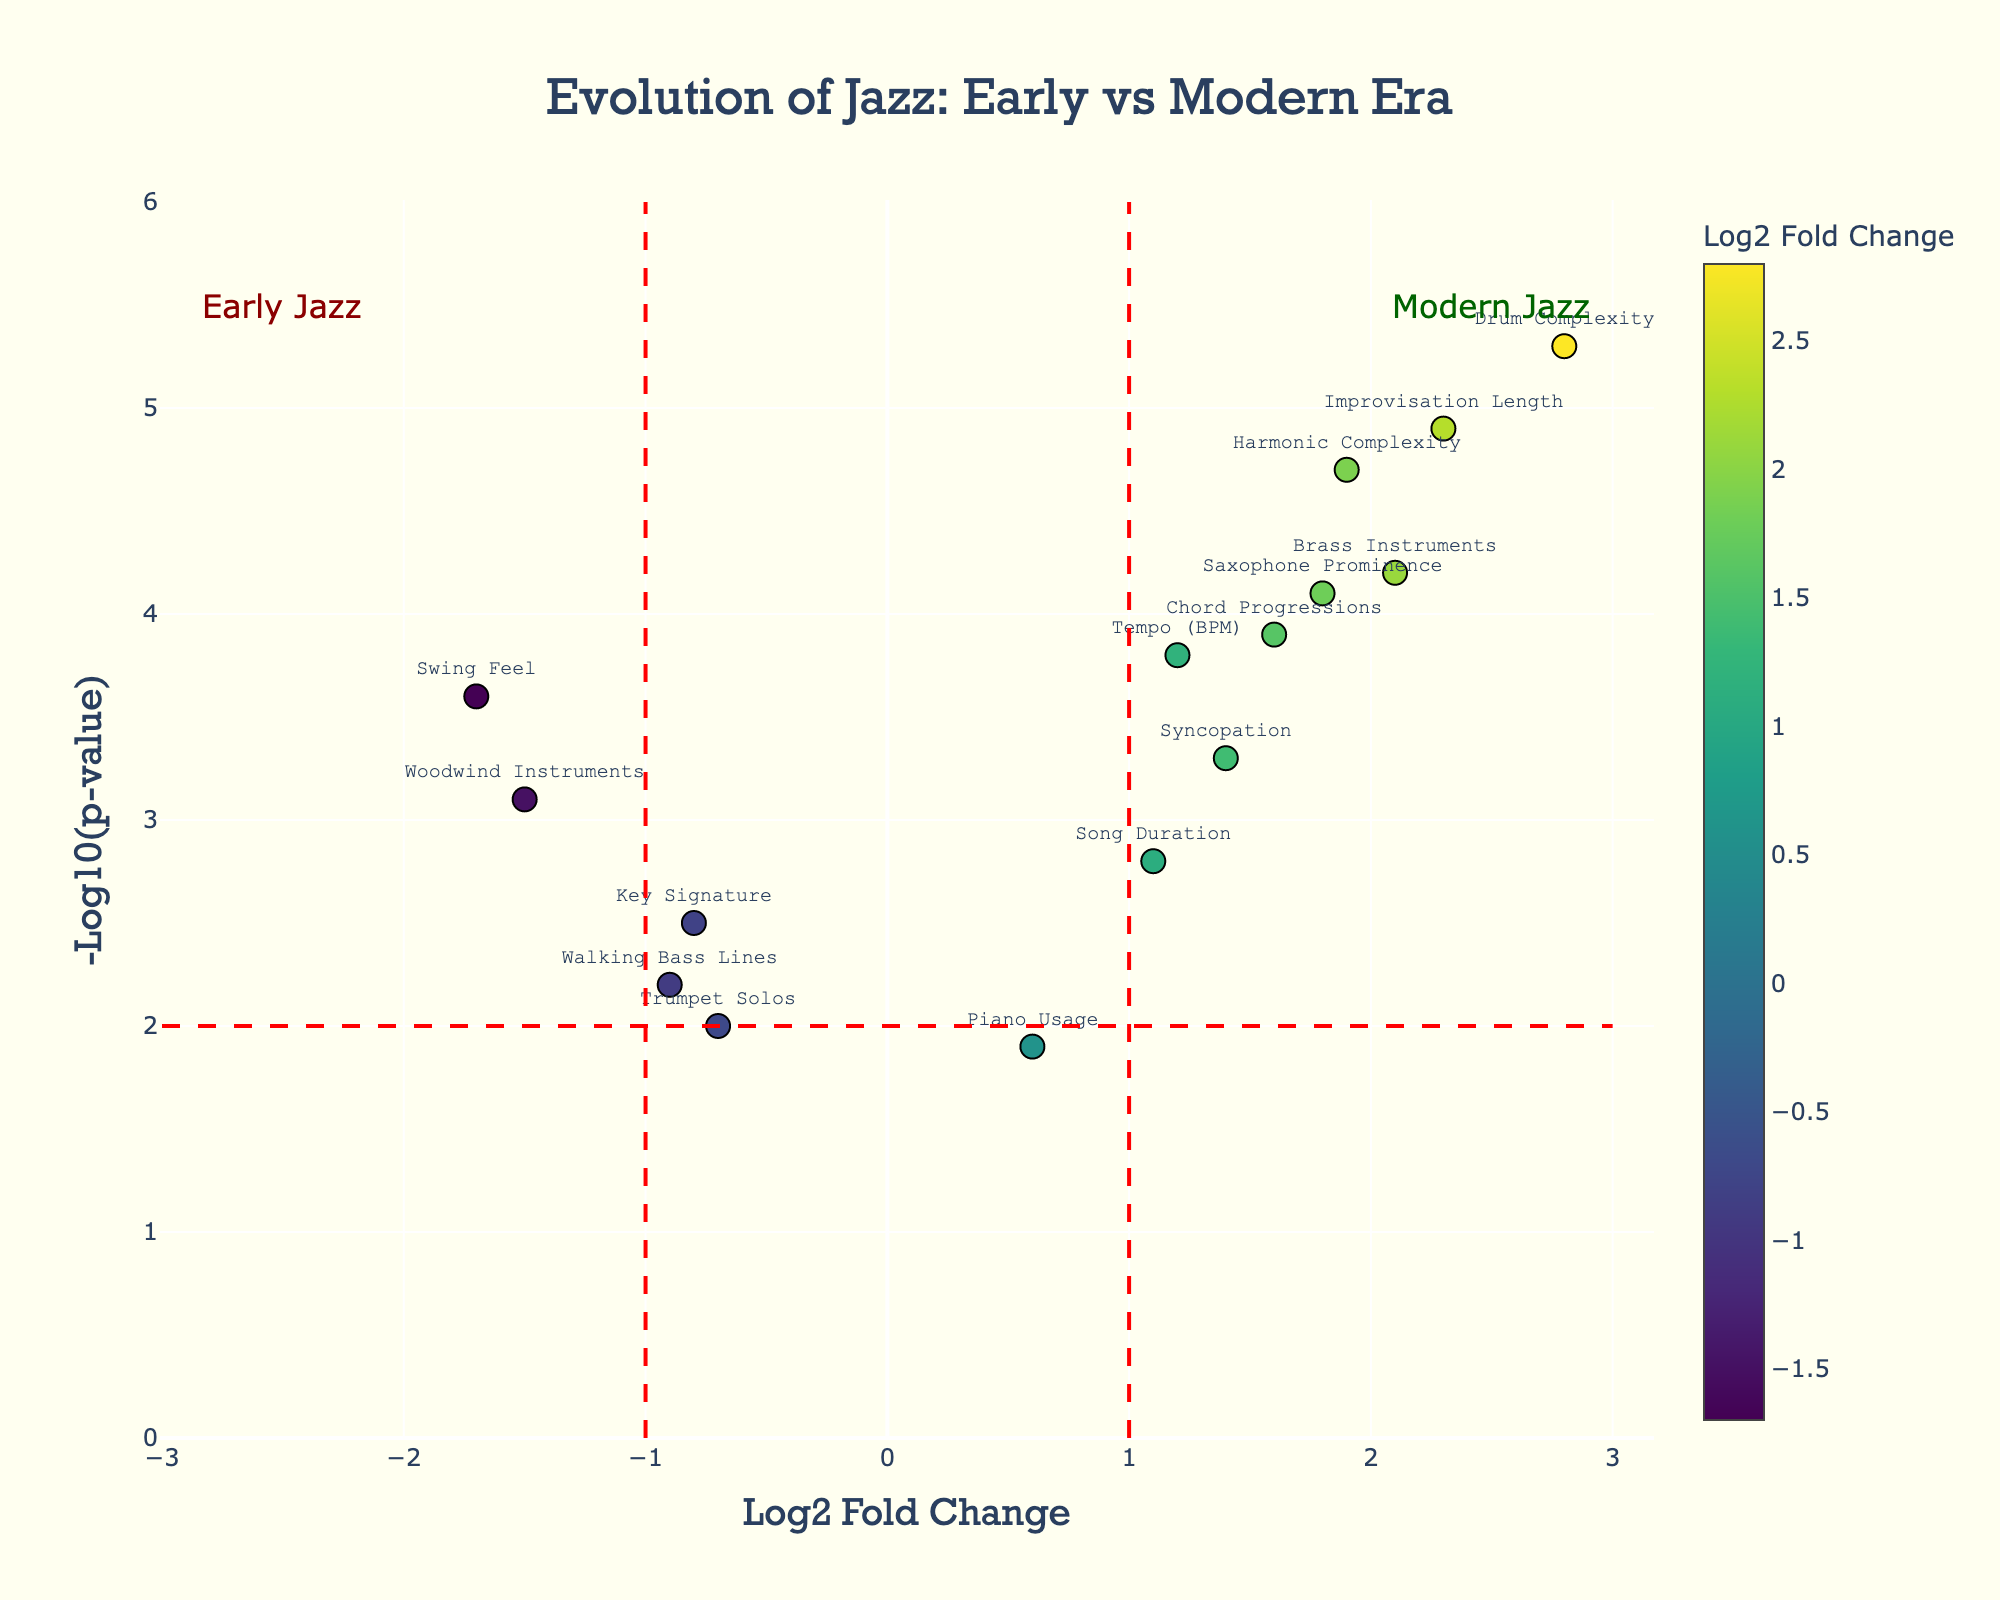What's the title of the plot? The title is usually located at the top of the plot. In this case, it reads, "Evolution of Jazz: Early vs Modern Era."
Answer: Evolution of Jazz: Early vs Modern Era What does the x-axis represent? The x-axis label provides information about what is being measured horizontally on the plot. Here, it indicates "Log2 Fold Change."
Answer: Log2 Fold Change Which musical element has the highest negative Log2 Fold Change? To find this, look for the data point farthest to the left along the x-axis which corresponds to a large negative value. The label indicates it is "Swing Feel."
Answer: Swing Feel How many musical elements have a -Log10(p-value) greater than 4? Identify the points above the 4 mark on the y-axis. They are "Brass Instruments," "Drum Complexity," "Harmonic Complexity," "Improvisation Length," and "Saxophone Prominence." Count them.
Answer: 5 Are there any musical elements with a Log2 Fold Change around 0? Look at the points near the vertical line where x = 0. The element "Piano Usage" is the closest.
Answer: Piano Usage Which musical elements indicate a trend towards modern jazz based on the plot? Elements with positive Log2 Fold Change suggest they are more common in modern jazz. These include "Tempo (BPM)," "Brass Instruments," "Drum Complexity," "Harmonic Complexity," "Improvisation Length," "Syncopation," "Chord Progressions," "Saxophone Prominence," and "Song Duration."
Answer: Tempo (BPM), Brass Instruments, Drum Complexity, Harmonic Complexity, Improvisation Length, Syncopation, Chord Progressions, Saxophone Prominence, Song Duration What is the Log2 Fold Change and -Log10(p-value) of "Drum Complexity"? Identify the data point labeled "Drum Complexity" and read the values on the x and y axes.
Answer: Log2 Fold Change: 2.8, -Log10(p-value): 5.3 Which element has the lowest -Log10(p-value)? Find the point at the lowest position on the y-axis. The label corresponds to "Trumpet Solos."
Answer: Trumpet Solos What is directly indicated by the color scale used in the plot? The color scale provides additional visual information about the Log2 Fold Change of each musical element, with different colors representing varying values.
Answer: Log2 Fold Change Based on the plot, which musical elements have a significant change (outside vertical red lines) from early to modern jazz? Elements outside of -1 and +1 Log2 Fold Changes indicate significant change. These include "Tempo (BPM)," "Brass Instruments," "Woodwind Instruments," "Drum Complexity," "Harmonic Complexity," "Improvisation Length," and "Swing Feel."
Answer: Tempo (BPM), Brass Instruments, Woodwind Instruments, Drum Complexity, Harmonic Complexity, Improvisation Length, Swing Feel 